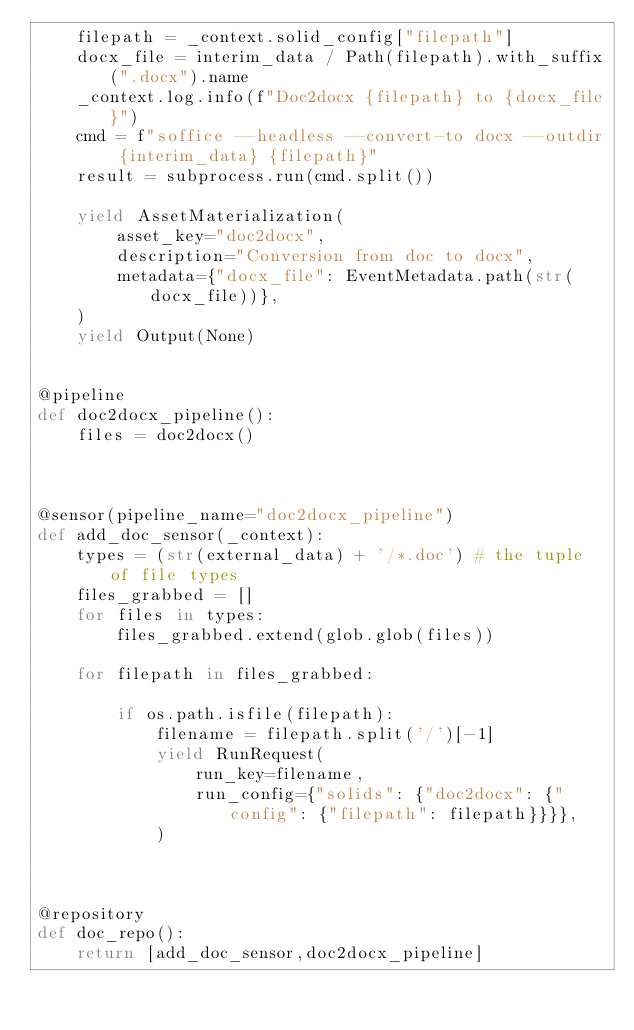Convert code to text. <code><loc_0><loc_0><loc_500><loc_500><_Python_>    filepath = _context.solid_config["filepath"]
    docx_file = interim_data / Path(filepath).with_suffix(".docx").name
    _context.log.info(f"Doc2docx {filepath} to {docx_file}")
    cmd = f"soffice --headless --convert-to docx --outdir {interim_data} {filepath}"
    result = subprocess.run(cmd.split())

    yield AssetMaterialization(
        asset_key="doc2docx",
        description="Conversion from doc to docx",
        metadata={"docx_file": EventMetadata.path(str(docx_file))},
    )
    yield Output(None)


@pipeline
def doc2docx_pipeline():
    files = doc2docx()



@sensor(pipeline_name="doc2docx_pipeline")
def add_doc_sensor(_context):
    types = (str(external_data) + '/*.doc') # the tuple of file types
    files_grabbed = []
    for files in types:
        files_grabbed.extend(glob.glob(files))

    for filepath in files_grabbed:
        
        if os.path.isfile(filepath):
            filename = filepath.split('/')[-1]
            yield RunRequest(
                run_key=filename,
                run_config={"solids": {"doc2docx": {"config": {"filepath": filepath}}}},
            )



@repository
def doc_repo():
    return [add_doc_sensor,doc2docx_pipeline]
</code> 